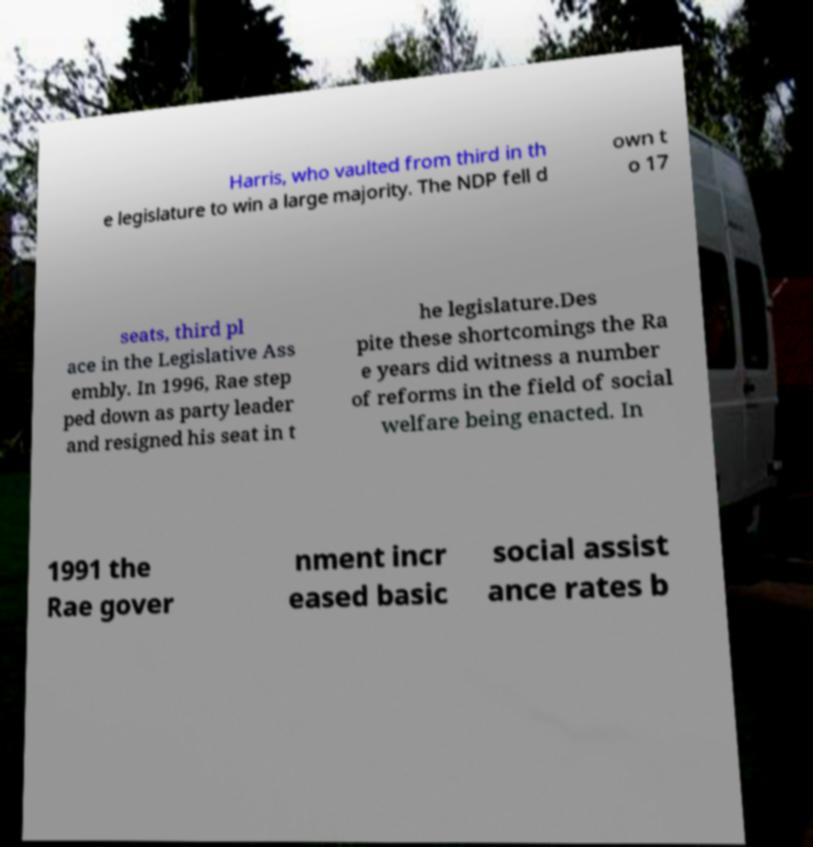Could you assist in decoding the text presented in this image and type it out clearly? Harris, who vaulted from third in th e legislature to win a large majority. The NDP fell d own t o 17 seats, third pl ace in the Legislative Ass embly. In 1996, Rae step ped down as party leader and resigned his seat in t he legislature.Des pite these shortcomings the Ra e years did witness a number of reforms in the field of social welfare being enacted. In 1991 the Rae gover nment incr eased basic social assist ance rates b 